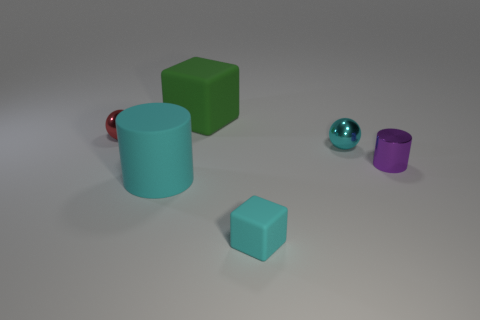Subtract all yellow spheres. Subtract all blue cylinders. How many spheres are left? 2 Add 4 big metal things. How many objects exist? 10 Subtract all spheres. How many objects are left? 4 Subtract all small green rubber blocks. Subtract all small red spheres. How many objects are left? 5 Add 4 green matte objects. How many green matte objects are left? 5 Add 4 big green matte objects. How many big green matte objects exist? 5 Subtract 0 green cylinders. How many objects are left? 6 